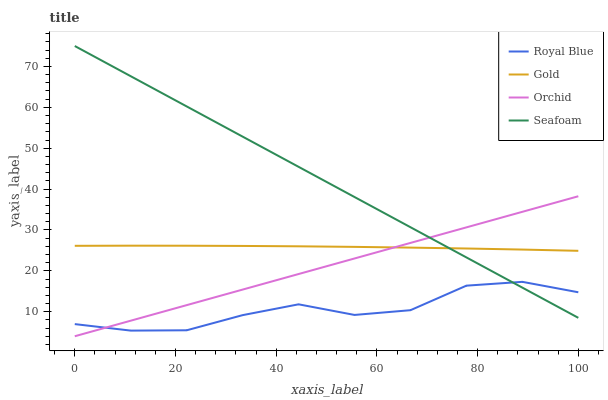Does Gold have the minimum area under the curve?
Answer yes or no. No. Does Gold have the maximum area under the curve?
Answer yes or no. No. Is Seafoam the smoothest?
Answer yes or no. No. Is Seafoam the roughest?
Answer yes or no. No. Does Seafoam have the lowest value?
Answer yes or no. No. Does Gold have the highest value?
Answer yes or no. No. Is Royal Blue less than Gold?
Answer yes or no. Yes. Is Gold greater than Royal Blue?
Answer yes or no. Yes. Does Royal Blue intersect Gold?
Answer yes or no. No. 